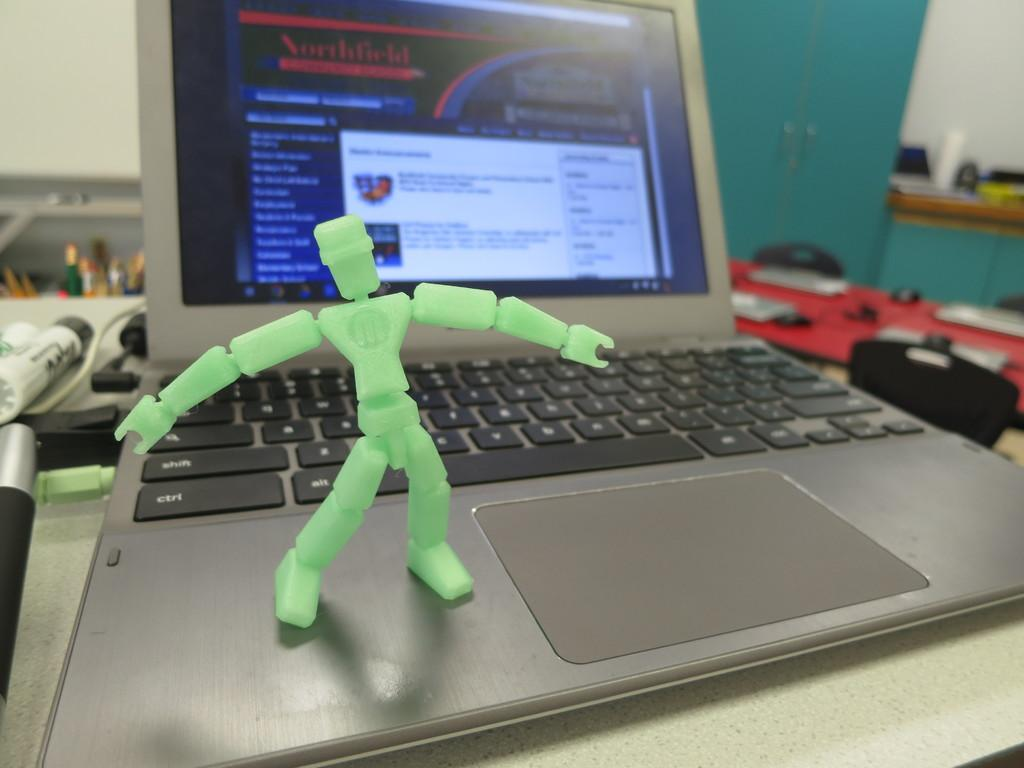<image>
Write a terse but informative summary of the picture. a web page for Northfield is on a computer that has a green toy on it 